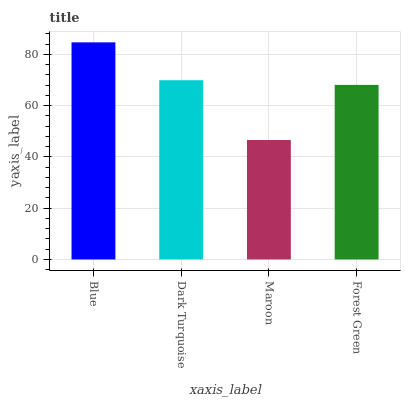Is Maroon the minimum?
Answer yes or no. Yes. Is Blue the maximum?
Answer yes or no. Yes. Is Dark Turquoise the minimum?
Answer yes or no. No. Is Dark Turquoise the maximum?
Answer yes or no. No. Is Blue greater than Dark Turquoise?
Answer yes or no. Yes. Is Dark Turquoise less than Blue?
Answer yes or no. Yes. Is Dark Turquoise greater than Blue?
Answer yes or no. No. Is Blue less than Dark Turquoise?
Answer yes or no. No. Is Dark Turquoise the high median?
Answer yes or no. Yes. Is Forest Green the low median?
Answer yes or no. Yes. Is Forest Green the high median?
Answer yes or no. No. Is Blue the low median?
Answer yes or no. No. 